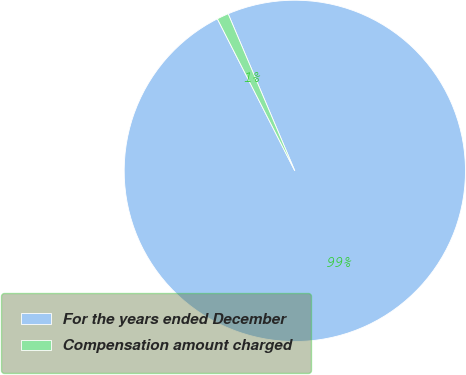<chart> <loc_0><loc_0><loc_500><loc_500><pie_chart><fcel>For the years ended December<fcel>Compensation amount charged<nl><fcel>98.89%<fcel>1.11%<nl></chart> 